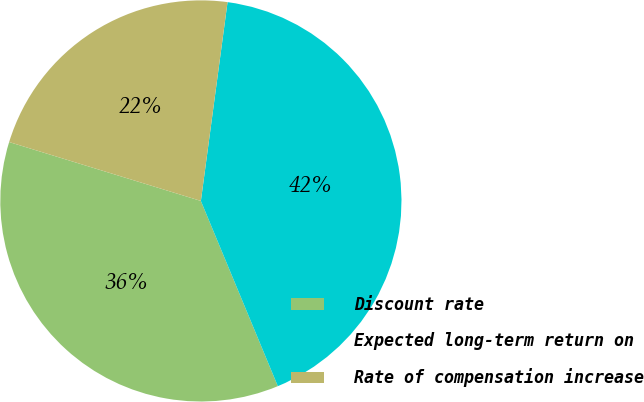Convert chart to OTSL. <chart><loc_0><loc_0><loc_500><loc_500><pie_chart><fcel>Discount rate<fcel>Expected long-term return on<fcel>Rate of compensation increase<nl><fcel>36.01%<fcel>41.61%<fcel>22.38%<nl></chart> 